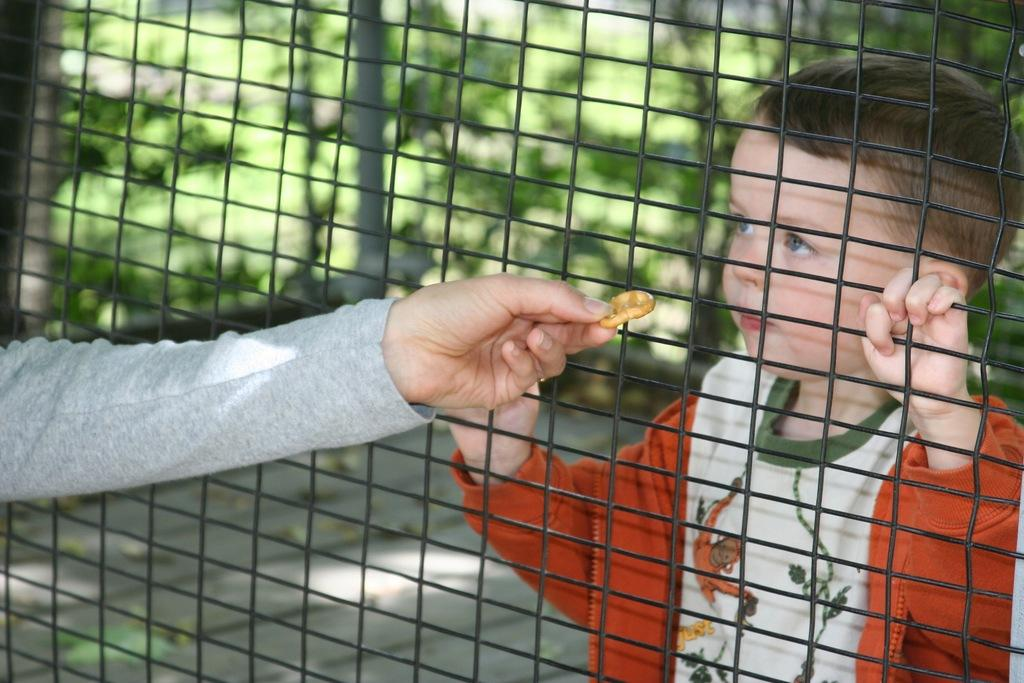What is the main subject of the image? The main subject of the image is a boy standing. What is the boy wearing in the image? The boy is wearing a jerkin and a T-shirt. Can you describe the hand and the object it is holding in the image? There is a person's hand holding a biscuit in the image. What is the background of the image made of? The image appears to be on a fencing sheet. Can you tell me how many bees are buzzing around the boy in the image? There are no bees present in the image. What letters can be seen on the boy's T-shirt in the image? The facts provided do not mention any letters on the boy's T-shirt, so we cannot determine if any letters are present. 